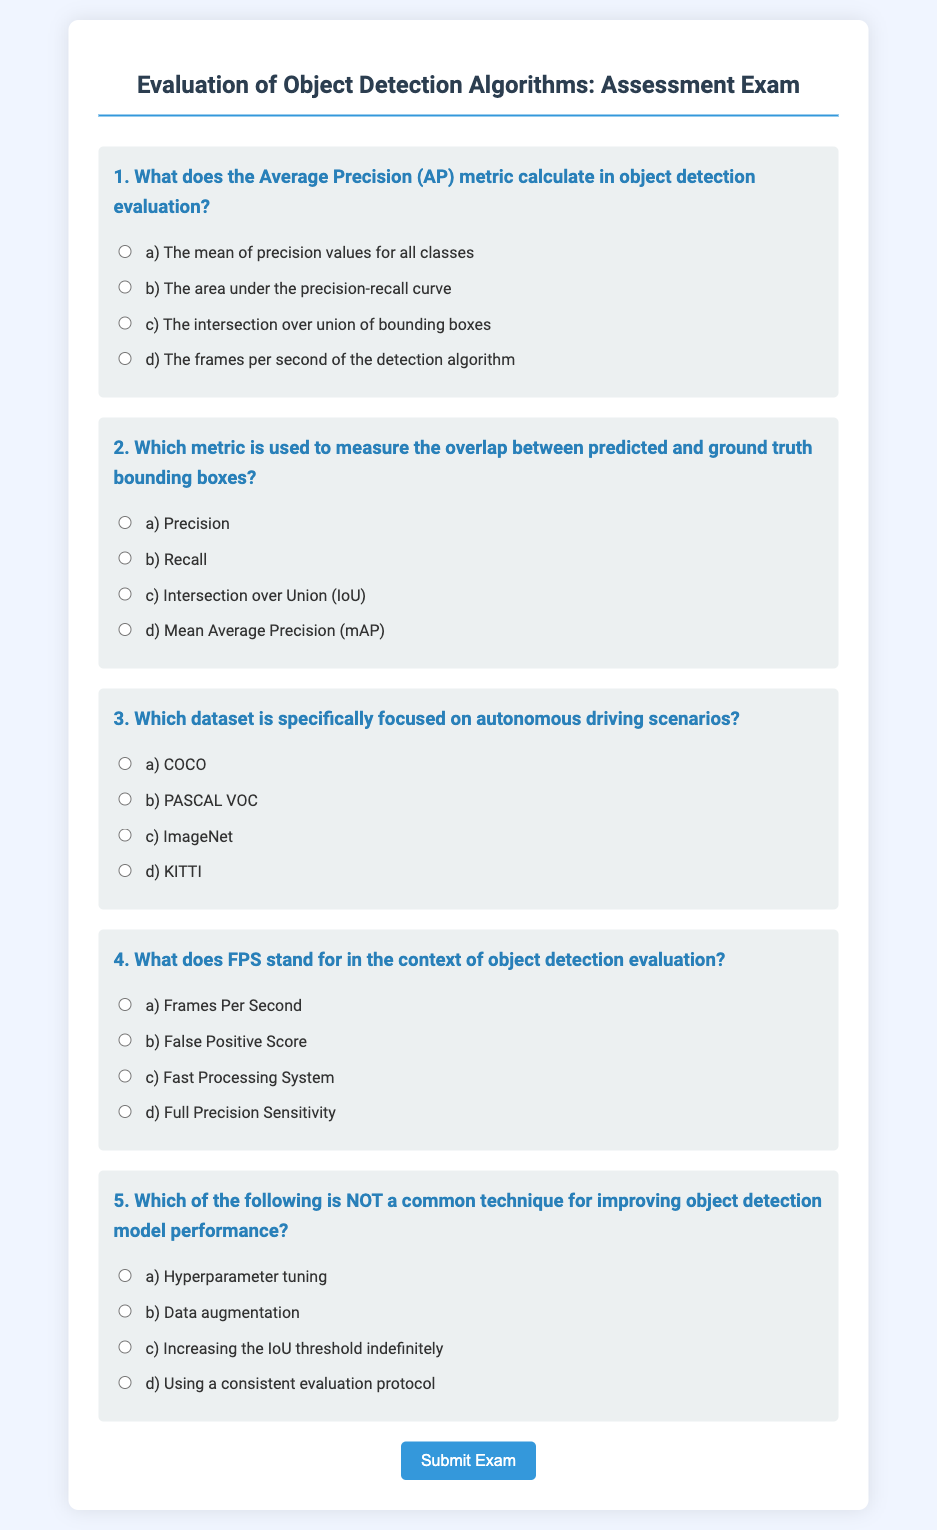What is the title of the exam? The title of the exam is written at the top of the document, and it is "Evaluation of Object Detection Algorithms: Assessment Exam".
Answer: Evaluation of Object Detection Algorithms: Assessment Exam What are the options provided for Question 1? The options provided for Question 1 can be found in the corresponding section of the document, which lists four possible answers labeled a, b, c, and d.
Answer: a) The mean of precision values for all classes, b) The area under the precision-recall curve, c) The intersection over union of bounding boxes, d) The frames per second of the detection algorithm How many questions are in the exam? The exam contains a total of five distinct questions based on the structure shown in the document.
Answer: 5 What does the abbreviation IoU stand for? IoU is used in the document as part of the second question, where it is associated with bounding boxes in object detection.
Answer: Intersection over Union What does the acronym mAP refer to? mAP is mentioned in the context of the metrics used in object detection evaluation, specifically in relation to precision and recall calculations.
Answer: Mean Average Precision 